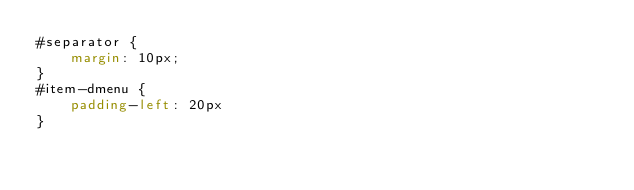<code> <loc_0><loc_0><loc_500><loc_500><_CSS_>#separator {
    margin: 10px;
}
#item-dmenu {
    padding-left: 20px
}
</code> 